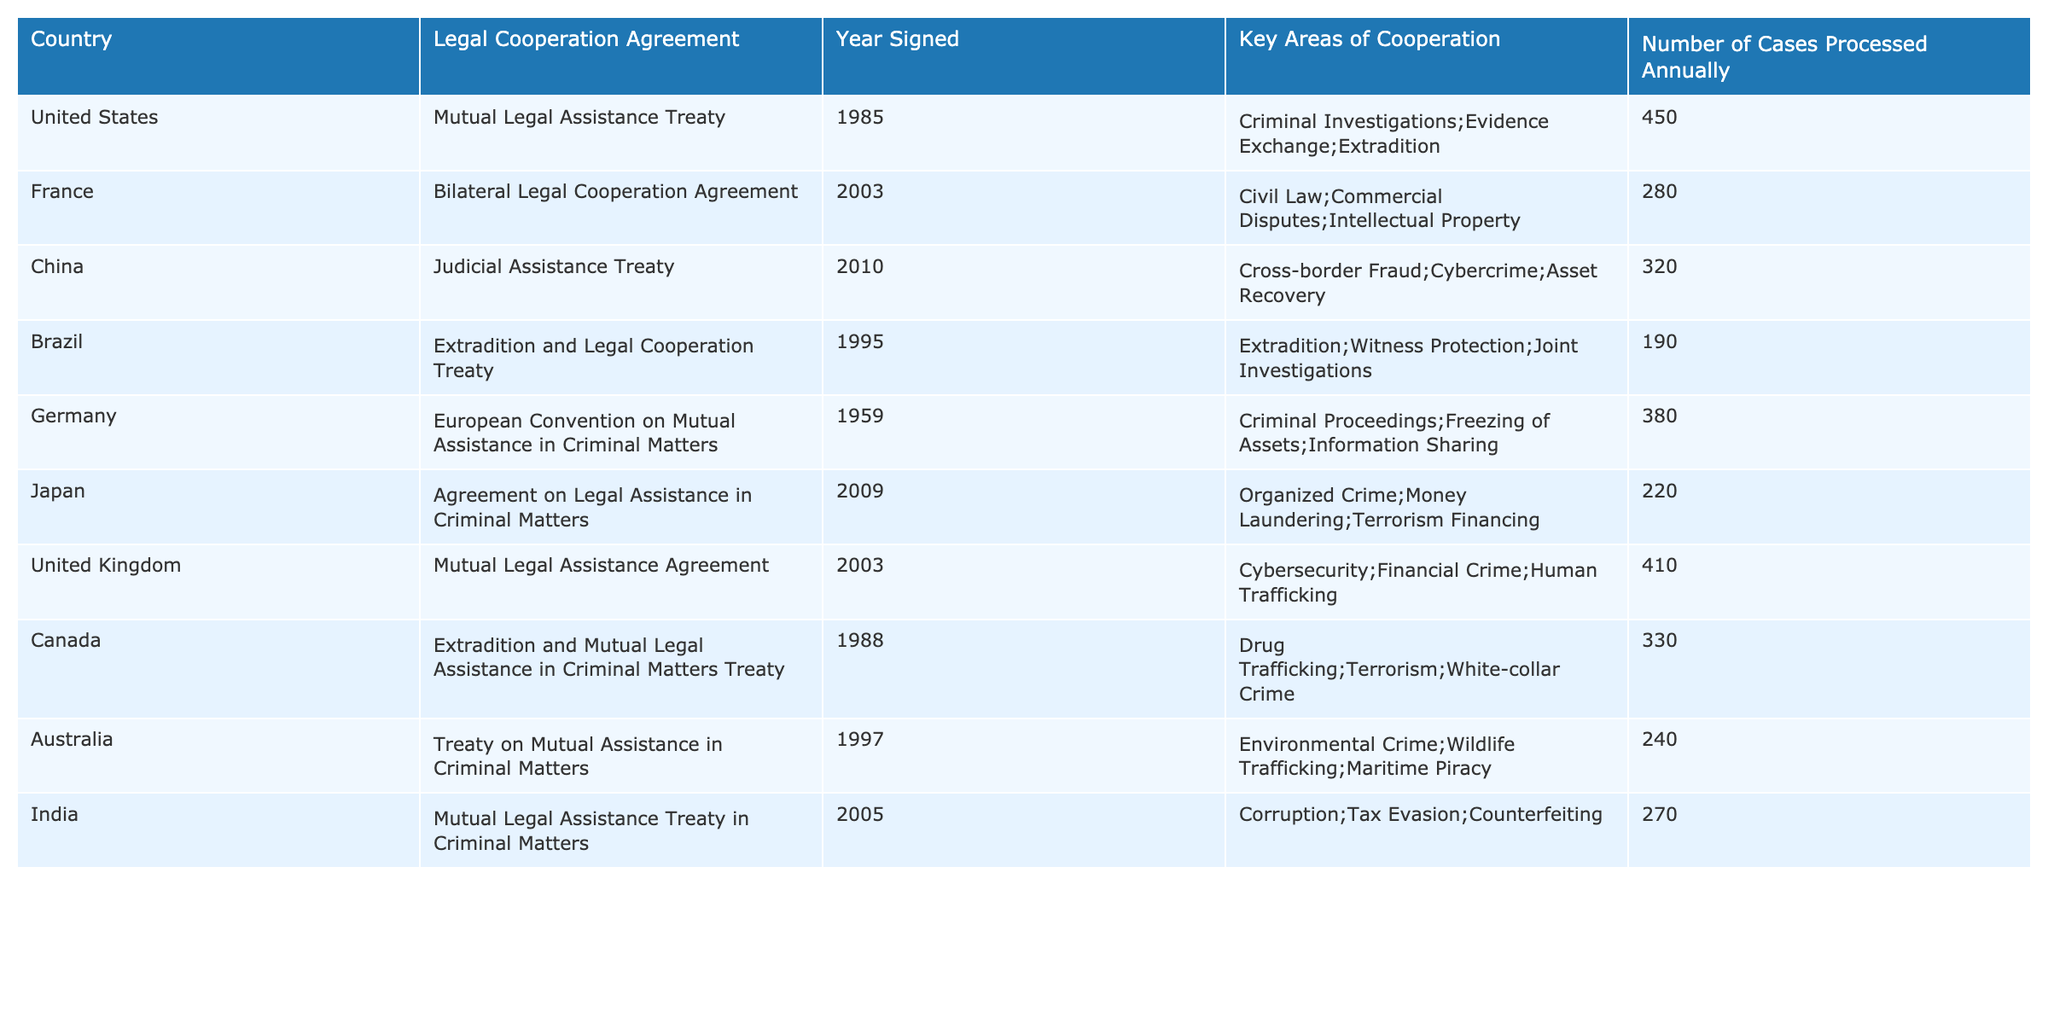What year was the Mutual Legal Assistance Treaty signed by the United States? The table indicates that the Mutual Legal Assistance Treaty was signed by the United States in the year 1985.
Answer: 1985 Which country has the highest number of cases processed annually? By examining the "Number of Cases Processed Annually" column, the United States processes the highest number of cases at 450.
Answer: United States How many cases are processed annually by Canada? The table displays that Canada processes 330 cases annually.
Answer: 330 Is there a legal cooperation agreement signed by Brazil in or after 2000? Brazil's Extradition and Legal Cooperation Treaty was signed in 1995, which is before 2000. Therefore, the answer is no.
Answer: No What are the key areas of cooperation for the agreement signed by China? The key areas of cooperation listed for China's Judicial Assistance Treaty signed in 2010 are Cross-border Fraud, Cybercrime, and Asset Recovery.
Answer: Cross-border Fraud; Cybercrime; Asset Recovery What is the average number of cases processed annually among all listed countries? Summing the number of cases processed: 450 + 280 + 320 + 190 + 380 + 220 + 410 + 330 + 240 + 270 = 2,570. There are 10 countries, so the average is 2,570 / 10 = 257.
Answer: 257 Which countries have signed agreements focused on criminal matters? The countries with agreements focused on criminal matters, based on the key areas of cooperation, are the United States, Germany, Japan, Canada, and India.
Answer: United States; Germany; Japan; Canada; India If we combine the cases processed by China and Japan, how many cases would that be? The cases processed annually by China and Japan are 320 and 220, respectively. Adding these together gives 320 + 220 = 540.
Answer: 540 Do any agreements focus on environmental crime? The agreement from Australia, titled "Treaty on Mutual Assistance in Criminal Matters," includes environmental crime as one of its key areas of cooperation. Therefore, the answer is yes.
Answer: Yes Which country signed a treaty in 1959, and what is the key area focused on? Germany signed the European Convention on Mutual Assistance in Criminal Matters in 1959, and its key areas of focus include Criminal Proceedings, Freezing of Assets, and Information Sharing.
Answer: Germany; Criminal Proceedings; Freezing of Assets; Information Sharing What is the difference in the number of cases processed between the United States and the United Kingdom? The United States processes 450 cases while the United Kingdom processes 410 cases. The difference between these two numbers is 450 - 410 = 40.
Answer: 40 